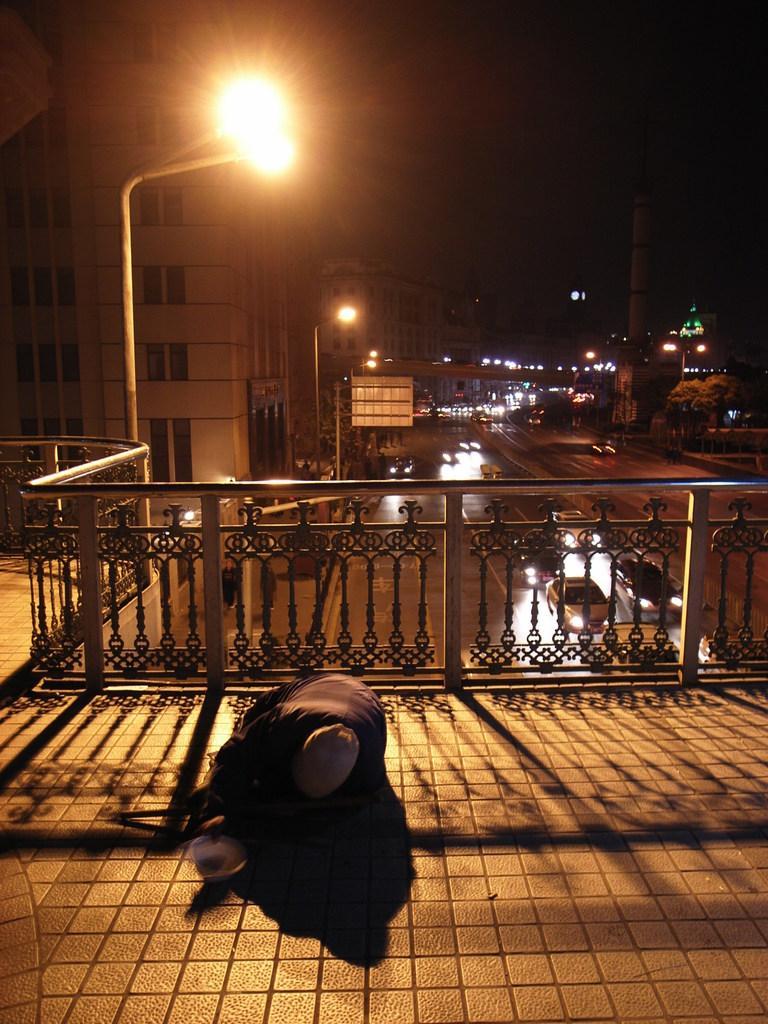How would you summarize this image in a sentence or two? In this picture we can see a person and railing in the front, there are some vehicles, poles, lights and a bridge in the middle, in the background there are buildings, we can see trees on the right side, there is the sky at the top of the picture. 